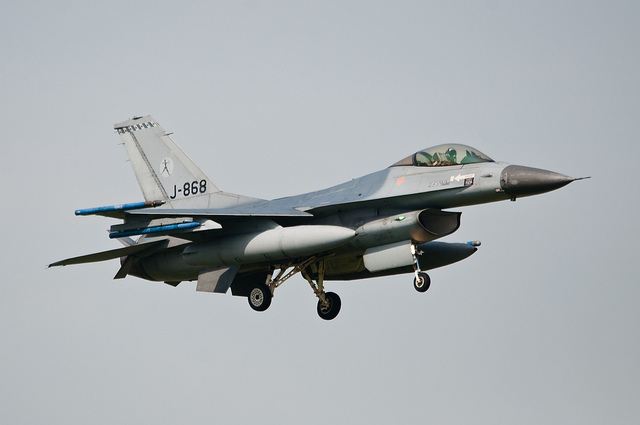<image>Why is someone on top of the airplane? There is no one on top of the airplane. It's ambiguous why someone would be there. Why is someone on top of the airplane? I don't know why someone is on top of the airplane. It can be for flying or piloting the airplane. 